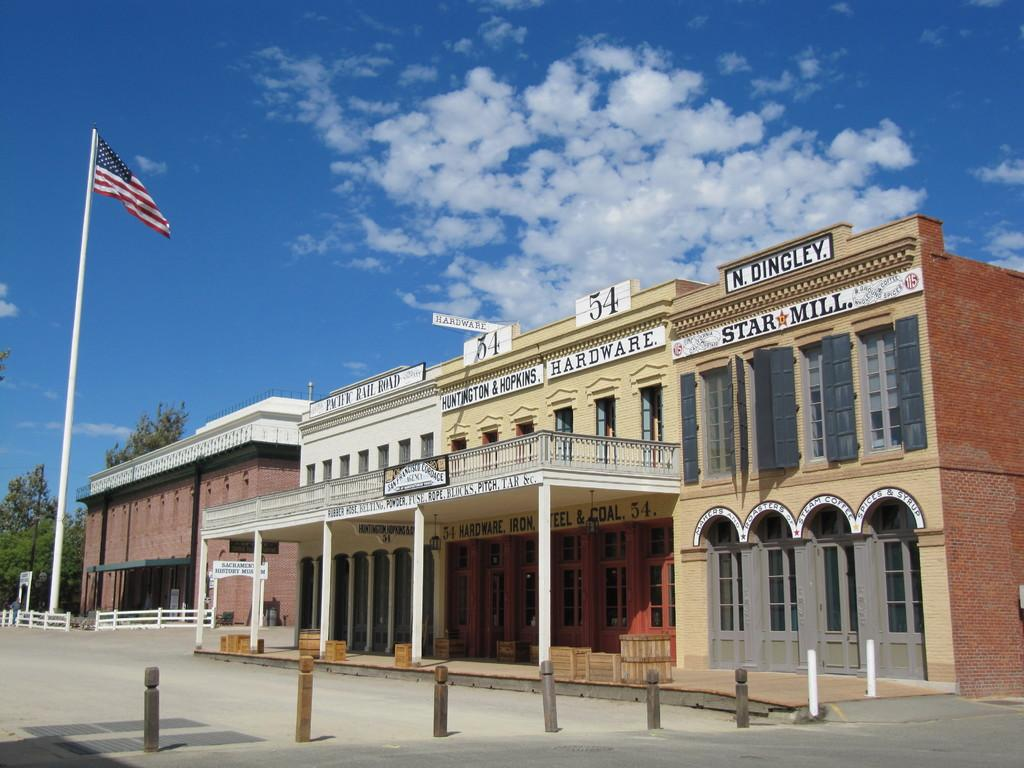What type of structures can be seen in the image? There are buildings in the image. Where is the American flag located in the image? The American flag is on the left side of the image. What else is on the left side of the image besides the flag? There are trees on the left side of the image. What can be seen in the background of the image? The sky is visible in the background of the image. What type of liquid is dripping from the wax in the image? There is no liquid or wax present in the image. 